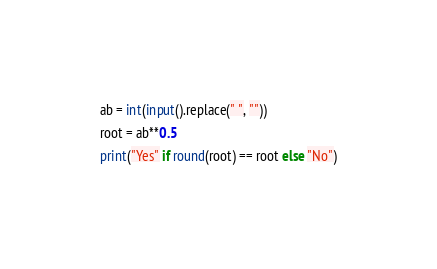<code> <loc_0><loc_0><loc_500><loc_500><_Python_>ab = int(input().replace(" ", ""))
root = ab**0.5
print("Yes" if round(root) == root else "No")</code> 